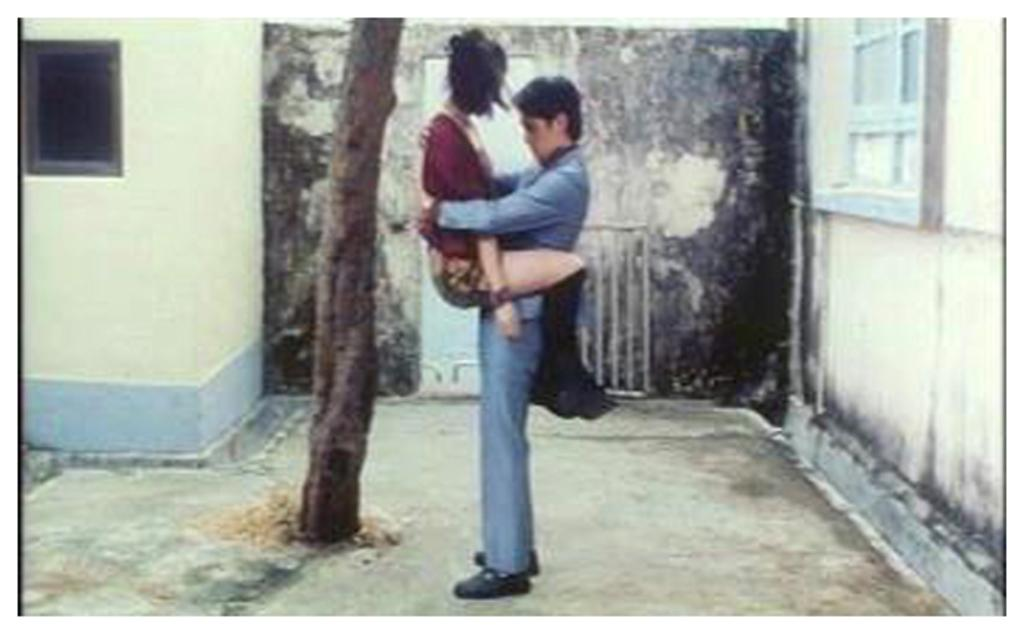What is the man in the image doing? The man is lifting a woman in the image. What type of clothing is the man wearing? The man is wearing a coat, trousers, and shoes. Can you describe the window in the image? There is a window on the left side of the image, and it is in a wall. What type of quilt is being used to cover the floor in the image? There is no quilt present in the image; it features a man lifting a woman. How hot is the room in the image? The temperature of the room is not mentioned in the image, so it cannot be determined. 